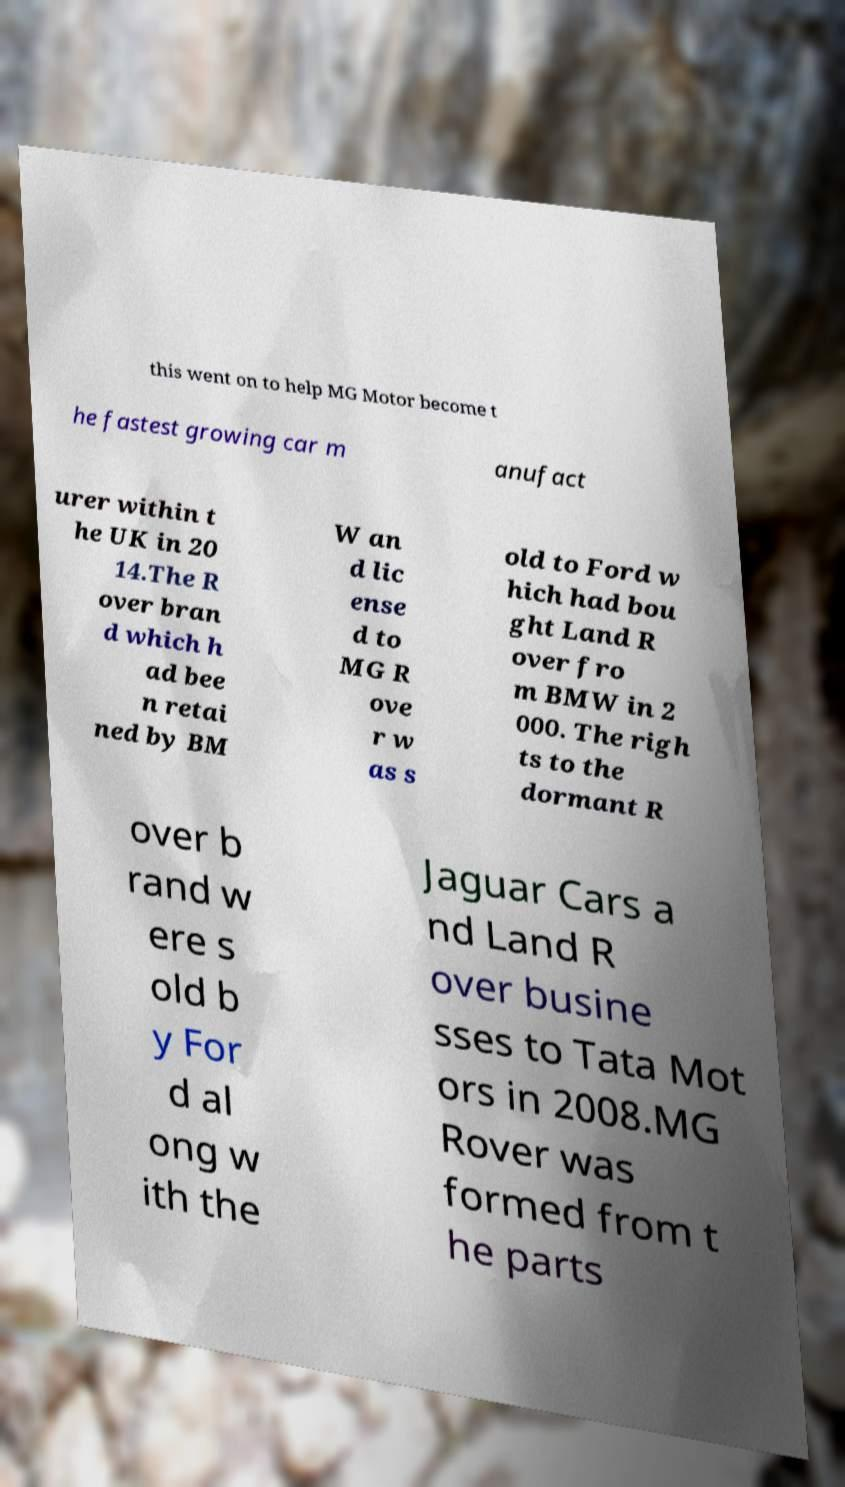Could you assist in decoding the text presented in this image and type it out clearly? this went on to help MG Motor become t he fastest growing car m anufact urer within t he UK in 20 14.The R over bran d which h ad bee n retai ned by BM W an d lic ense d to MG R ove r w as s old to Ford w hich had bou ght Land R over fro m BMW in 2 000. The righ ts to the dormant R over b rand w ere s old b y For d al ong w ith the Jaguar Cars a nd Land R over busine sses to Tata Mot ors in 2008.MG Rover was formed from t he parts 